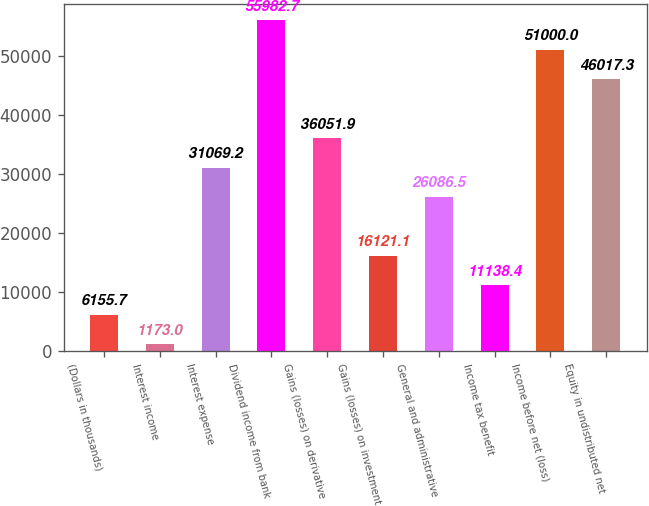Convert chart to OTSL. <chart><loc_0><loc_0><loc_500><loc_500><bar_chart><fcel>(Dollars in thousands)<fcel>Interest income<fcel>Interest expense<fcel>Dividend income from bank<fcel>Gains (losses) on derivative<fcel>Gains (losses) on investment<fcel>General and administrative<fcel>Income tax benefit<fcel>Income before net (loss)<fcel>Equity in undistributed net<nl><fcel>6155.7<fcel>1173<fcel>31069.2<fcel>55982.7<fcel>36051.9<fcel>16121.1<fcel>26086.5<fcel>11138.4<fcel>51000<fcel>46017.3<nl></chart> 